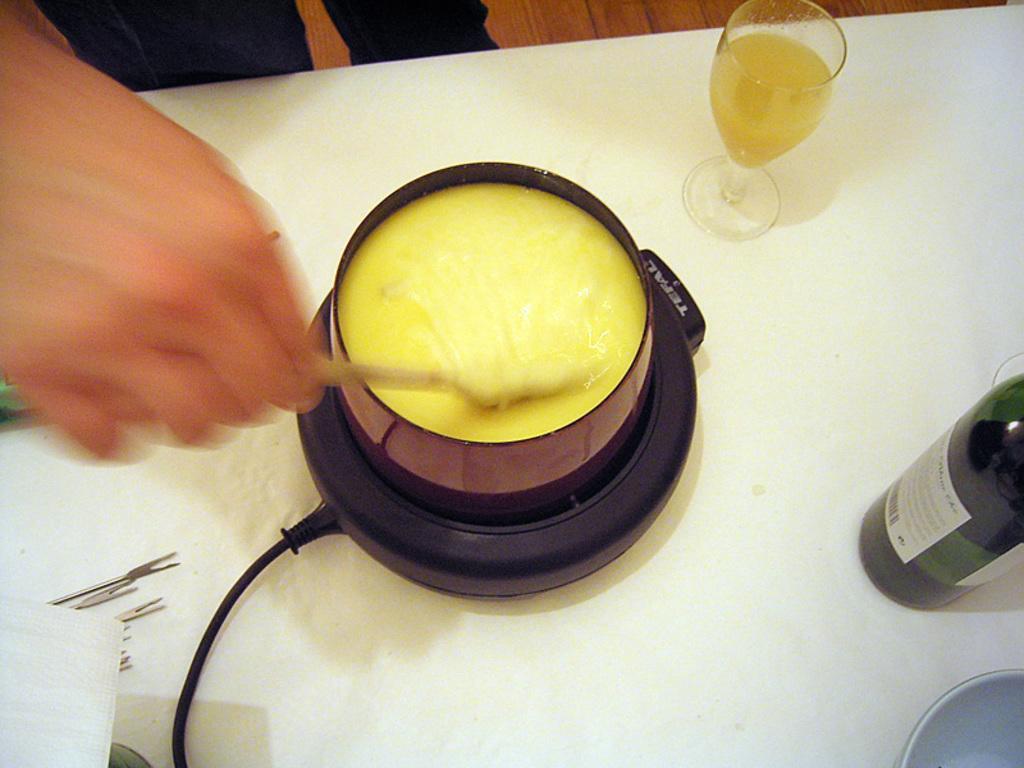How would you summarize this image in a sentence or two? In this picture there is a person holding a spoon , There is a cup, glass, bowl, bottle and few objects on the table. 